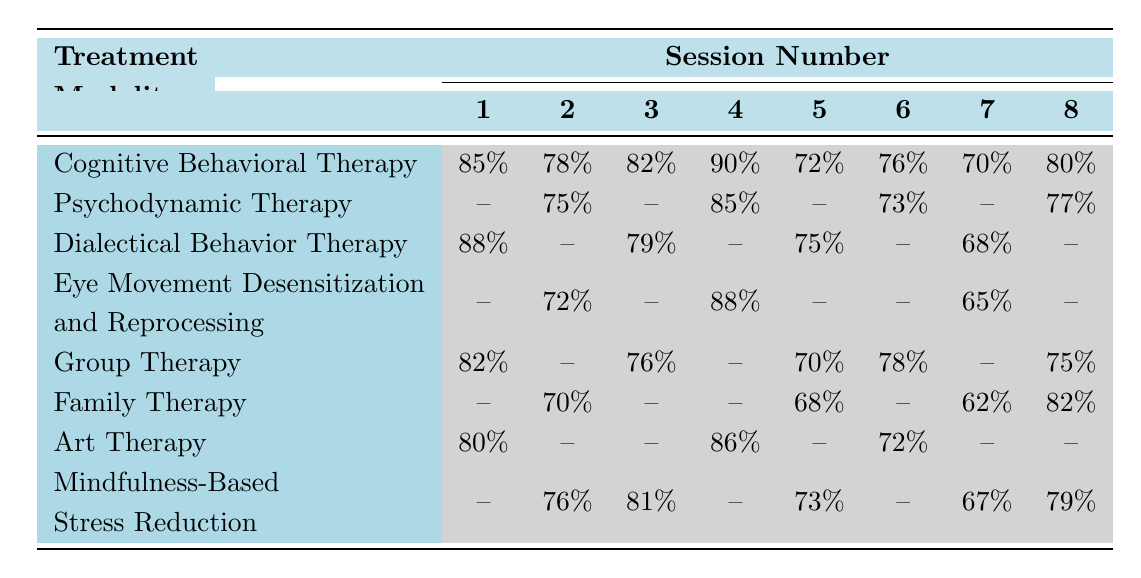What is the attendance rate for Cognitive Behavioral Therapy in the fifth session? In the table, under the Cognitive Behavioral Therapy row, the attendance rate for the fifth session is 72%.
Answer: 72% What treatment modality had an attendance rate of 88% in any session? Looking through the table, only Dialectical Behavior Therapy shows an attendance rate of 88% in the fourth session.
Answer: Yes How many modalities show attendance rates for all eight sessions? By inspecting the table, Cognitive Behavioral Therapy is the only modality with attendance rates listed for all eight sessions.
Answer: 1 What is the average attendance rate for Group Therapy across all sessions? The attendance rates for Group Therapy are 82%, 76%, 70%, 78%, and 75% in sessions 1, 3, 5, 6, and 8. The average is calculated as (82 + 76 + 70 + 78 + 75) / 5 = 76.2%.
Answer: Approximately 76.2% Is there any treatment modality that had a zero attendance rate in any of the sessions? Yes, by scanning the table, Psychodynamic Therapy and family therapy both have zero attendance rates in some sessions.
Answer: Yes Which treatment modality had the highest attendance rate in session 1? The attendance rates for session 1 are 85% for Cognitive Behavioral Therapy, 0% for Psychodynamic Therapy, and 88% for Dialectical Behavior Therapy, therefore Dialectical Behavior Therapy had the highest at 88%.
Answer: Dialectical Behavior Therapy What is the difference in attendance rates between the highest and lowest rates for Mindfulness-Based Stress Reduction? For Mindfulness-Based Stress Reduction, the highest rate is 81% in session 3 and the lowest is 67% in session 7. The difference is 81% - 67% = 14%.
Answer: 14% Which therapy had the worst attendance in session 2? In session 2, looking through the table, Psychodynamic Therapy had 75%, while others had higher or zero values, making it the lowest.
Answer: Psychodynamic Therapy What treatment modalities have an attendance rate for session 4? Reviewing the table shows attendance rates for session 4 from Cognitive Behavioral Therapy, Psychodynamic Therapy, Dialectical Behavior Therapy, and Eye Movement Desensitization and Reprocessing.
Answer: 4 modalities How do the attendance rates for Family Therapy compare with Art Therapy across all sessions? Comparing the two modalities shows Family Therapy (0, 70, 0, 0, 68, 0, 62, 82) has higher attendance rates in sessions 2, 5, 7, and 8 compared to Art Therapy (80, 0, 0, 86, 0, 72, 0, 0).
Answer: Family Therapy is higher in 4 sessions, Art Therapy in 1 session What is the total attendance in the first session across all treatment modalities? Summing the attendance rates for the first session: 85 + 0 + 88 + 0 + 82 + 0 + 80 + 0 = 335.
Answer: 335 